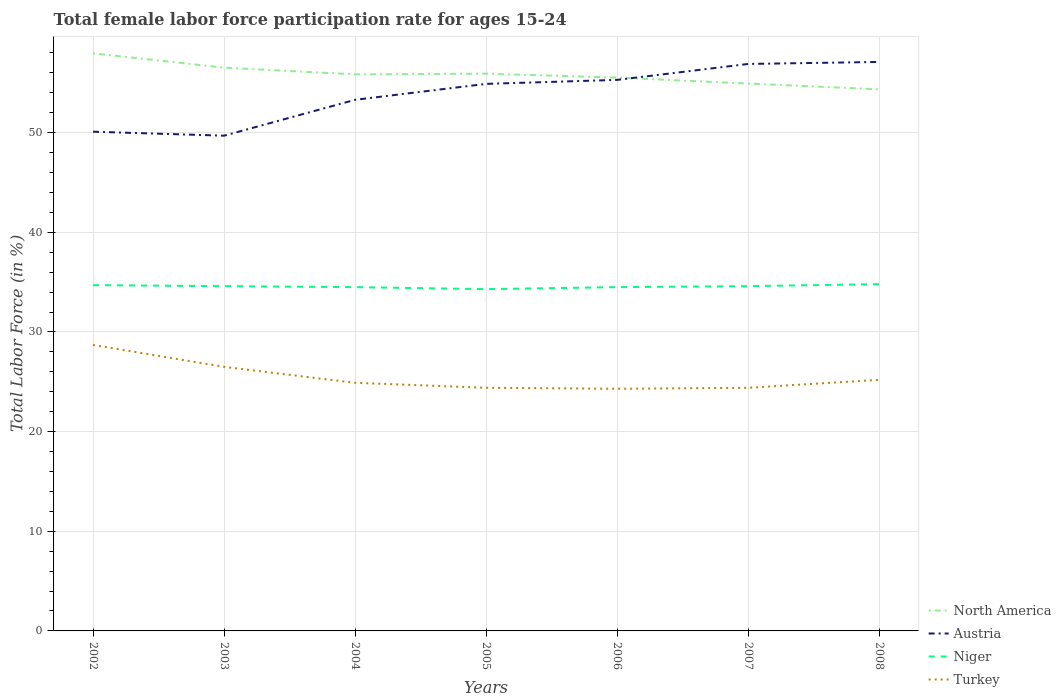Across all years, what is the maximum female labor force participation rate in Austria?
Ensure brevity in your answer.  49.7. In which year was the female labor force participation rate in Niger maximum?
Offer a terse response. 2005. What is the total female labor force participation rate in Austria in the graph?
Offer a terse response. -5.2. What is the difference between the highest and the second highest female labor force participation rate in Turkey?
Provide a succinct answer. 4.4. Is the female labor force participation rate in Niger strictly greater than the female labor force participation rate in Austria over the years?
Your answer should be very brief. Yes. How many lines are there?
Give a very brief answer. 4. Does the graph contain any zero values?
Keep it short and to the point. No. How many legend labels are there?
Provide a succinct answer. 4. How are the legend labels stacked?
Your answer should be compact. Vertical. What is the title of the graph?
Your response must be concise. Total female labor force participation rate for ages 15-24. Does "Benin" appear as one of the legend labels in the graph?
Provide a short and direct response. No. What is the label or title of the X-axis?
Provide a short and direct response. Years. What is the Total Labor Force (in %) in North America in 2002?
Provide a short and direct response. 57.96. What is the Total Labor Force (in %) in Austria in 2002?
Ensure brevity in your answer.  50.1. What is the Total Labor Force (in %) of Niger in 2002?
Keep it short and to the point. 34.7. What is the Total Labor Force (in %) of Turkey in 2002?
Offer a very short reply. 28.7. What is the Total Labor Force (in %) in North America in 2003?
Your response must be concise. 56.53. What is the Total Labor Force (in %) in Austria in 2003?
Your answer should be very brief. 49.7. What is the Total Labor Force (in %) of Niger in 2003?
Offer a very short reply. 34.6. What is the Total Labor Force (in %) in North America in 2004?
Your response must be concise. 55.85. What is the Total Labor Force (in %) in Austria in 2004?
Provide a short and direct response. 53.3. What is the Total Labor Force (in %) in Niger in 2004?
Offer a terse response. 34.5. What is the Total Labor Force (in %) in Turkey in 2004?
Make the answer very short. 24.9. What is the Total Labor Force (in %) of North America in 2005?
Your response must be concise. 55.92. What is the Total Labor Force (in %) in Austria in 2005?
Ensure brevity in your answer.  54.9. What is the Total Labor Force (in %) in Niger in 2005?
Give a very brief answer. 34.3. What is the Total Labor Force (in %) in Turkey in 2005?
Keep it short and to the point. 24.4. What is the Total Labor Force (in %) of North America in 2006?
Ensure brevity in your answer.  55.53. What is the Total Labor Force (in %) in Austria in 2006?
Give a very brief answer. 55.3. What is the Total Labor Force (in %) in Niger in 2006?
Provide a short and direct response. 34.5. What is the Total Labor Force (in %) in Turkey in 2006?
Provide a short and direct response. 24.3. What is the Total Labor Force (in %) of North America in 2007?
Make the answer very short. 54.93. What is the Total Labor Force (in %) of Austria in 2007?
Your response must be concise. 56.9. What is the Total Labor Force (in %) of Niger in 2007?
Your answer should be compact. 34.6. What is the Total Labor Force (in %) in Turkey in 2007?
Offer a terse response. 24.4. What is the Total Labor Force (in %) of North America in 2008?
Your answer should be compact. 54.35. What is the Total Labor Force (in %) in Austria in 2008?
Offer a very short reply. 57.1. What is the Total Labor Force (in %) in Niger in 2008?
Give a very brief answer. 34.8. What is the Total Labor Force (in %) of Turkey in 2008?
Offer a very short reply. 25.2. Across all years, what is the maximum Total Labor Force (in %) of North America?
Give a very brief answer. 57.96. Across all years, what is the maximum Total Labor Force (in %) of Austria?
Keep it short and to the point. 57.1. Across all years, what is the maximum Total Labor Force (in %) of Niger?
Offer a terse response. 34.8. Across all years, what is the maximum Total Labor Force (in %) in Turkey?
Your answer should be very brief. 28.7. Across all years, what is the minimum Total Labor Force (in %) in North America?
Keep it short and to the point. 54.35. Across all years, what is the minimum Total Labor Force (in %) of Austria?
Give a very brief answer. 49.7. Across all years, what is the minimum Total Labor Force (in %) of Niger?
Your answer should be very brief. 34.3. Across all years, what is the minimum Total Labor Force (in %) of Turkey?
Offer a terse response. 24.3. What is the total Total Labor Force (in %) in North America in the graph?
Your answer should be very brief. 391.08. What is the total Total Labor Force (in %) of Austria in the graph?
Give a very brief answer. 377.3. What is the total Total Labor Force (in %) of Niger in the graph?
Your answer should be very brief. 242. What is the total Total Labor Force (in %) of Turkey in the graph?
Your answer should be compact. 178.4. What is the difference between the Total Labor Force (in %) in North America in 2002 and that in 2003?
Give a very brief answer. 1.43. What is the difference between the Total Labor Force (in %) in Niger in 2002 and that in 2003?
Offer a very short reply. 0.1. What is the difference between the Total Labor Force (in %) in Turkey in 2002 and that in 2003?
Your answer should be very brief. 2.2. What is the difference between the Total Labor Force (in %) in North America in 2002 and that in 2004?
Keep it short and to the point. 2.11. What is the difference between the Total Labor Force (in %) of Niger in 2002 and that in 2004?
Your response must be concise. 0.2. What is the difference between the Total Labor Force (in %) of North America in 2002 and that in 2005?
Offer a very short reply. 2.04. What is the difference between the Total Labor Force (in %) in Austria in 2002 and that in 2005?
Your answer should be compact. -4.8. What is the difference between the Total Labor Force (in %) of Turkey in 2002 and that in 2005?
Provide a succinct answer. 4.3. What is the difference between the Total Labor Force (in %) in North America in 2002 and that in 2006?
Your answer should be very brief. 2.43. What is the difference between the Total Labor Force (in %) of North America in 2002 and that in 2007?
Offer a very short reply. 3.03. What is the difference between the Total Labor Force (in %) of Austria in 2002 and that in 2007?
Provide a short and direct response. -6.8. What is the difference between the Total Labor Force (in %) in Turkey in 2002 and that in 2007?
Your response must be concise. 4.3. What is the difference between the Total Labor Force (in %) of North America in 2002 and that in 2008?
Provide a succinct answer. 3.61. What is the difference between the Total Labor Force (in %) in North America in 2003 and that in 2004?
Provide a short and direct response. 0.67. What is the difference between the Total Labor Force (in %) of Niger in 2003 and that in 2004?
Your response must be concise. 0.1. What is the difference between the Total Labor Force (in %) of North America in 2003 and that in 2005?
Give a very brief answer. 0.6. What is the difference between the Total Labor Force (in %) of Austria in 2003 and that in 2005?
Your answer should be compact. -5.2. What is the difference between the Total Labor Force (in %) in Niger in 2003 and that in 2005?
Keep it short and to the point. 0.3. What is the difference between the Total Labor Force (in %) in Turkey in 2003 and that in 2005?
Give a very brief answer. 2.1. What is the difference between the Total Labor Force (in %) of Niger in 2003 and that in 2006?
Offer a terse response. 0.1. What is the difference between the Total Labor Force (in %) in North America in 2003 and that in 2007?
Your answer should be compact. 1.6. What is the difference between the Total Labor Force (in %) of Austria in 2003 and that in 2007?
Keep it short and to the point. -7.2. What is the difference between the Total Labor Force (in %) in Niger in 2003 and that in 2007?
Your response must be concise. 0. What is the difference between the Total Labor Force (in %) in Turkey in 2003 and that in 2007?
Your response must be concise. 2.1. What is the difference between the Total Labor Force (in %) in North America in 2003 and that in 2008?
Offer a terse response. 2.18. What is the difference between the Total Labor Force (in %) in Austria in 2003 and that in 2008?
Your response must be concise. -7.4. What is the difference between the Total Labor Force (in %) of Niger in 2003 and that in 2008?
Provide a short and direct response. -0.2. What is the difference between the Total Labor Force (in %) in North America in 2004 and that in 2005?
Ensure brevity in your answer.  -0.07. What is the difference between the Total Labor Force (in %) of Niger in 2004 and that in 2005?
Your answer should be compact. 0.2. What is the difference between the Total Labor Force (in %) in Turkey in 2004 and that in 2005?
Your response must be concise. 0.5. What is the difference between the Total Labor Force (in %) of North America in 2004 and that in 2006?
Your answer should be very brief. 0.32. What is the difference between the Total Labor Force (in %) in Niger in 2004 and that in 2006?
Give a very brief answer. 0. What is the difference between the Total Labor Force (in %) in Turkey in 2004 and that in 2006?
Your answer should be compact. 0.6. What is the difference between the Total Labor Force (in %) in North America in 2004 and that in 2007?
Offer a very short reply. 0.92. What is the difference between the Total Labor Force (in %) of North America in 2004 and that in 2008?
Provide a short and direct response. 1.51. What is the difference between the Total Labor Force (in %) in Niger in 2004 and that in 2008?
Keep it short and to the point. -0.3. What is the difference between the Total Labor Force (in %) in North America in 2005 and that in 2006?
Make the answer very short. 0.39. What is the difference between the Total Labor Force (in %) of Austria in 2005 and that in 2006?
Give a very brief answer. -0.4. What is the difference between the Total Labor Force (in %) in Niger in 2005 and that in 2006?
Your response must be concise. -0.2. What is the difference between the Total Labor Force (in %) of North America in 2005 and that in 2007?
Provide a succinct answer. 0.99. What is the difference between the Total Labor Force (in %) of Niger in 2005 and that in 2007?
Your answer should be very brief. -0.3. What is the difference between the Total Labor Force (in %) in Turkey in 2005 and that in 2007?
Your answer should be very brief. 0. What is the difference between the Total Labor Force (in %) in North America in 2005 and that in 2008?
Your answer should be compact. 1.57. What is the difference between the Total Labor Force (in %) of Austria in 2005 and that in 2008?
Give a very brief answer. -2.2. What is the difference between the Total Labor Force (in %) of Niger in 2005 and that in 2008?
Provide a succinct answer. -0.5. What is the difference between the Total Labor Force (in %) in Turkey in 2005 and that in 2008?
Your answer should be compact. -0.8. What is the difference between the Total Labor Force (in %) of North America in 2006 and that in 2007?
Your response must be concise. 0.6. What is the difference between the Total Labor Force (in %) of Austria in 2006 and that in 2007?
Offer a very short reply. -1.6. What is the difference between the Total Labor Force (in %) of Niger in 2006 and that in 2007?
Offer a terse response. -0.1. What is the difference between the Total Labor Force (in %) in North America in 2006 and that in 2008?
Your answer should be very brief. 1.18. What is the difference between the Total Labor Force (in %) of Niger in 2006 and that in 2008?
Keep it short and to the point. -0.3. What is the difference between the Total Labor Force (in %) of North America in 2007 and that in 2008?
Provide a succinct answer. 0.58. What is the difference between the Total Labor Force (in %) in Niger in 2007 and that in 2008?
Offer a very short reply. -0.2. What is the difference between the Total Labor Force (in %) of North America in 2002 and the Total Labor Force (in %) of Austria in 2003?
Give a very brief answer. 8.26. What is the difference between the Total Labor Force (in %) of North America in 2002 and the Total Labor Force (in %) of Niger in 2003?
Give a very brief answer. 23.36. What is the difference between the Total Labor Force (in %) in North America in 2002 and the Total Labor Force (in %) in Turkey in 2003?
Give a very brief answer. 31.46. What is the difference between the Total Labor Force (in %) in Austria in 2002 and the Total Labor Force (in %) in Niger in 2003?
Provide a short and direct response. 15.5. What is the difference between the Total Labor Force (in %) in Austria in 2002 and the Total Labor Force (in %) in Turkey in 2003?
Keep it short and to the point. 23.6. What is the difference between the Total Labor Force (in %) in North America in 2002 and the Total Labor Force (in %) in Austria in 2004?
Your answer should be very brief. 4.66. What is the difference between the Total Labor Force (in %) of North America in 2002 and the Total Labor Force (in %) of Niger in 2004?
Offer a terse response. 23.46. What is the difference between the Total Labor Force (in %) of North America in 2002 and the Total Labor Force (in %) of Turkey in 2004?
Provide a succinct answer. 33.06. What is the difference between the Total Labor Force (in %) in Austria in 2002 and the Total Labor Force (in %) in Turkey in 2004?
Offer a very short reply. 25.2. What is the difference between the Total Labor Force (in %) of North America in 2002 and the Total Labor Force (in %) of Austria in 2005?
Offer a very short reply. 3.06. What is the difference between the Total Labor Force (in %) in North America in 2002 and the Total Labor Force (in %) in Niger in 2005?
Offer a very short reply. 23.66. What is the difference between the Total Labor Force (in %) of North America in 2002 and the Total Labor Force (in %) of Turkey in 2005?
Your answer should be very brief. 33.56. What is the difference between the Total Labor Force (in %) of Austria in 2002 and the Total Labor Force (in %) of Niger in 2005?
Provide a short and direct response. 15.8. What is the difference between the Total Labor Force (in %) in Austria in 2002 and the Total Labor Force (in %) in Turkey in 2005?
Your answer should be very brief. 25.7. What is the difference between the Total Labor Force (in %) of North America in 2002 and the Total Labor Force (in %) of Austria in 2006?
Your answer should be compact. 2.66. What is the difference between the Total Labor Force (in %) of North America in 2002 and the Total Labor Force (in %) of Niger in 2006?
Ensure brevity in your answer.  23.46. What is the difference between the Total Labor Force (in %) in North America in 2002 and the Total Labor Force (in %) in Turkey in 2006?
Provide a short and direct response. 33.66. What is the difference between the Total Labor Force (in %) in Austria in 2002 and the Total Labor Force (in %) in Turkey in 2006?
Keep it short and to the point. 25.8. What is the difference between the Total Labor Force (in %) of Niger in 2002 and the Total Labor Force (in %) of Turkey in 2006?
Give a very brief answer. 10.4. What is the difference between the Total Labor Force (in %) of North America in 2002 and the Total Labor Force (in %) of Austria in 2007?
Provide a short and direct response. 1.06. What is the difference between the Total Labor Force (in %) of North America in 2002 and the Total Labor Force (in %) of Niger in 2007?
Give a very brief answer. 23.36. What is the difference between the Total Labor Force (in %) in North America in 2002 and the Total Labor Force (in %) in Turkey in 2007?
Keep it short and to the point. 33.56. What is the difference between the Total Labor Force (in %) of Austria in 2002 and the Total Labor Force (in %) of Turkey in 2007?
Keep it short and to the point. 25.7. What is the difference between the Total Labor Force (in %) of Niger in 2002 and the Total Labor Force (in %) of Turkey in 2007?
Your response must be concise. 10.3. What is the difference between the Total Labor Force (in %) in North America in 2002 and the Total Labor Force (in %) in Austria in 2008?
Offer a very short reply. 0.86. What is the difference between the Total Labor Force (in %) of North America in 2002 and the Total Labor Force (in %) of Niger in 2008?
Your response must be concise. 23.16. What is the difference between the Total Labor Force (in %) in North America in 2002 and the Total Labor Force (in %) in Turkey in 2008?
Offer a terse response. 32.76. What is the difference between the Total Labor Force (in %) of Austria in 2002 and the Total Labor Force (in %) of Niger in 2008?
Give a very brief answer. 15.3. What is the difference between the Total Labor Force (in %) in Austria in 2002 and the Total Labor Force (in %) in Turkey in 2008?
Give a very brief answer. 24.9. What is the difference between the Total Labor Force (in %) in North America in 2003 and the Total Labor Force (in %) in Austria in 2004?
Offer a very short reply. 3.23. What is the difference between the Total Labor Force (in %) in North America in 2003 and the Total Labor Force (in %) in Niger in 2004?
Your answer should be compact. 22.03. What is the difference between the Total Labor Force (in %) in North America in 2003 and the Total Labor Force (in %) in Turkey in 2004?
Keep it short and to the point. 31.63. What is the difference between the Total Labor Force (in %) in Austria in 2003 and the Total Labor Force (in %) in Niger in 2004?
Your answer should be compact. 15.2. What is the difference between the Total Labor Force (in %) of Austria in 2003 and the Total Labor Force (in %) of Turkey in 2004?
Provide a short and direct response. 24.8. What is the difference between the Total Labor Force (in %) in North America in 2003 and the Total Labor Force (in %) in Austria in 2005?
Make the answer very short. 1.63. What is the difference between the Total Labor Force (in %) of North America in 2003 and the Total Labor Force (in %) of Niger in 2005?
Keep it short and to the point. 22.23. What is the difference between the Total Labor Force (in %) in North America in 2003 and the Total Labor Force (in %) in Turkey in 2005?
Ensure brevity in your answer.  32.13. What is the difference between the Total Labor Force (in %) in Austria in 2003 and the Total Labor Force (in %) in Turkey in 2005?
Make the answer very short. 25.3. What is the difference between the Total Labor Force (in %) of Niger in 2003 and the Total Labor Force (in %) of Turkey in 2005?
Your answer should be very brief. 10.2. What is the difference between the Total Labor Force (in %) of North America in 2003 and the Total Labor Force (in %) of Austria in 2006?
Ensure brevity in your answer.  1.23. What is the difference between the Total Labor Force (in %) of North America in 2003 and the Total Labor Force (in %) of Niger in 2006?
Your answer should be compact. 22.03. What is the difference between the Total Labor Force (in %) in North America in 2003 and the Total Labor Force (in %) in Turkey in 2006?
Your answer should be very brief. 32.23. What is the difference between the Total Labor Force (in %) in Austria in 2003 and the Total Labor Force (in %) in Niger in 2006?
Provide a short and direct response. 15.2. What is the difference between the Total Labor Force (in %) of Austria in 2003 and the Total Labor Force (in %) of Turkey in 2006?
Your answer should be very brief. 25.4. What is the difference between the Total Labor Force (in %) of North America in 2003 and the Total Labor Force (in %) of Austria in 2007?
Your answer should be compact. -0.37. What is the difference between the Total Labor Force (in %) in North America in 2003 and the Total Labor Force (in %) in Niger in 2007?
Your answer should be compact. 21.93. What is the difference between the Total Labor Force (in %) in North America in 2003 and the Total Labor Force (in %) in Turkey in 2007?
Your answer should be compact. 32.13. What is the difference between the Total Labor Force (in %) in Austria in 2003 and the Total Labor Force (in %) in Turkey in 2007?
Offer a very short reply. 25.3. What is the difference between the Total Labor Force (in %) of Niger in 2003 and the Total Labor Force (in %) of Turkey in 2007?
Your answer should be compact. 10.2. What is the difference between the Total Labor Force (in %) in North America in 2003 and the Total Labor Force (in %) in Austria in 2008?
Your answer should be very brief. -0.57. What is the difference between the Total Labor Force (in %) in North America in 2003 and the Total Labor Force (in %) in Niger in 2008?
Ensure brevity in your answer.  21.73. What is the difference between the Total Labor Force (in %) of North America in 2003 and the Total Labor Force (in %) of Turkey in 2008?
Offer a terse response. 31.33. What is the difference between the Total Labor Force (in %) in Austria in 2003 and the Total Labor Force (in %) in Niger in 2008?
Your response must be concise. 14.9. What is the difference between the Total Labor Force (in %) of Austria in 2003 and the Total Labor Force (in %) of Turkey in 2008?
Provide a short and direct response. 24.5. What is the difference between the Total Labor Force (in %) of North America in 2004 and the Total Labor Force (in %) of Austria in 2005?
Make the answer very short. 0.95. What is the difference between the Total Labor Force (in %) of North America in 2004 and the Total Labor Force (in %) of Niger in 2005?
Keep it short and to the point. 21.55. What is the difference between the Total Labor Force (in %) in North America in 2004 and the Total Labor Force (in %) in Turkey in 2005?
Offer a terse response. 31.45. What is the difference between the Total Labor Force (in %) of Austria in 2004 and the Total Labor Force (in %) of Niger in 2005?
Make the answer very short. 19. What is the difference between the Total Labor Force (in %) in Austria in 2004 and the Total Labor Force (in %) in Turkey in 2005?
Give a very brief answer. 28.9. What is the difference between the Total Labor Force (in %) of Niger in 2004 and the Total Labor Force (in %) of Turkey in 2005?
Provide a succinct answer. 10.1. What is the difference between the Total Labor Force (in %) of North America in 2004 and the Total Labor Force (in %) of Austria in 2006?
Ensure brevity in your answer.  0.55. What is the difference between the Total Labor Force (in %) in North America in 2004 and the Total Labor Force (in %) in Niger in 2006?
Offer a terse response. 21.35. What is the difference between the Total Labor Force (in %) in North America in 2004 and the Total Labor Force (in %) in Turkey in 2006?
Give a very brief answer. 31.55. What is the difference between the Total Labor Force (in %) of Austria in 2004 and the Total Labor Force (in %) of Turkey in 2006?
Provide a succinct answer. 29. What is the difference between the Total Labor Force (in %) in North America in 2004 and the Total Labor Force (in %) in Austria in 2007?
Make the answer very short. -1.05. What is the difference between the Total Labor Force (in %) in North America in 2004 and the Total Labor Force (in %) in Niger in 2007?
Provide a short and direct response. 21.25. What is the difference between the Total Labor Force (in %) in North America in 2004 and the Total Labor Force (in %) in Turkey in 2007?
Your answer should be compact. 31.45. What is the difference between the Total Labor Force (in %) of Austria in 2004 and the Total Labor Force (in %) of Niger in 2007?
Your answer should be very brief. 18.7. What is the difference between the Total Labor Force (in %) of Austria in 2004 and the Total Labor Force (in %) of Turkey in 2007?
Offer a terse response. 28.9. What is the difference between the Total Labor Force (in %) of Niger in 2004 and the Total Labor Force (in %) of Turkey in 2007?
Keep it short and to the point. 10.1. What is the difference between the Total Labor Force (in %) in North America in 2004 and the Total Labor Force (in %) in Austria in 2008?
Offer a terse response. -1.25. What is the difference between the Total Labor Force (in %) of North America in 2004 and the Total Labor Force (in %) of Niger in 2008?
Provide a succinct answer. 21.05. What is the difference between the Total Labor Force (in %) of North America in 2004 and the Total Labor Force (in %) of Turkey in 2008?
Keep it short and to the point. 30.65. What is the difference between the Total Labor Force (in %) in Austria in 2004 and the Total Labor Force (in %) in Niger in 2008?
Ensure brevity in your answer.  18.5. What is the difference between the Total Labor Force (in %) of Austria in 2004 and the Total Labor Force (in %) of Turkey in 2008?
Your response must be concise. 28.1. What is the difference between the Total Labor Force (in %) of Niger in 2004 and the Total Labor Force (in %) of Turkey in 2008?
Ensure brevity in your answer.  9.3. What is the difference between the Total Labor Force (in %) of North America in 2005 and the Total Labor Force (in %) of Austria in 2006?
Your response must be concise. 0.62. What is the difference between the Total Labor Force (in %) of North America in 2005 and the Total Labor Force (in %) of Niger in 2006?
Offer a terse response. 21.42. What is the difference between the Total Labor Force (in %) in North America in 2005 and the Total Labor Force (in %) in Turkey in 2006?
Your response must be concise. 31.62. What is the difference between the Total Labor Force (in %) in Austria in 2005 and the Total Labor Force (in %) in Niger in 2006?
Your answer should be compact. 20.4. What is the difference between the Total Labor Force (in %) in Austria in 2005 and the Total Labor Force (in %) in Turkey in 2006?
Keep it short and to the point. 30.6. What is the difference between the Total Labor Force (in %) in Niger in 2005 and the Total Labor Force (in %) in Turkey in 2006?
Provide a succinct answer. 10. What is the difference between the Total Labor Force (in %) of North America in 2005 and the Total Labor Force (in %) of Austria in 2007?
Your answer should be very brief. -0.98. What is the difference between the Total Labor Force (in %) in North America in 2005 and the Total Labor Force (in %) in Niger in 2007?
Your answer should be very brief. 21.32. What is the difference between the Total Labor Force (in %) in North America in 2005 and the Total Labor Force (in %) in Turkey in 2007?
Provide a short and direct response. 31.52. What is the difference between the Total Labor Force (in %) in Austria in 2005 and the Total Labor Force (in %) in Niger in 2007?
Your response must be concise. 20.3. What is the difference between the Total Labor Force (in %) of Austria in 2005 and the Total Labor Force (in %) of Turkey in 2007?
Your answer should be compact. 30.5. What is the difference between the Total Labor Force (in %) of Niger in 2005 and the Total Labor Force (in %) of Turkey in 2007?
Offer a terse response. 9.9. What is the difference between the Total Labor Force (in %) of North America in 2005 and the Total Labor Force (in %) of Austria in 2008?
Your answer should be compact. -1.18. What is the difference between the Total Labor Force (in %) of North America in 2005 and the Total Labor Force (in %) of Niger in 2008?
Keep it short and to the point. 21.12. What is the difference between the Total Labor Force (in %) of North America in 2005 and the Total Labor Force (in %) of Turkey in 2008?
Your answer should be very brief. 30.72. What is the difference between the Total Labor Force (in %) in Austria in 2005 and the Total Labor Force (in %) in Niger in 2008?
Offer a very short reply. 20.1. What is the difference between the Total Labor Force (in %) in Austria in 2005 and the Total Labor Force (in %) in Turkey in 2008?
Provide a short and direct response. 29.7. What is the difference between the Total Labor Force (in %) of Niger in 2005 and the Total Labor Force (in %) of Turkey in 2008?
Offer a very short reply. 9.1. What is the difference between the Total Labor Force (in %) in North America in 2006 and the Total Labor Force (in %) in Austria in 2007?
Provide a short and direct response. -1.37. What is the difference between the Total Labor Force (in %) in North America in 2006 and the Total Labor Force (in %) in Niger in 2007?
Ensure brevity in your answer.  20.93. What is the difference between the Total Labor Force (in %) of North America in 2006 and the Total Labor Force (in %) of Turkey in 2007?
Offer a very short reply. 31.13. What is the difference between the Total Labor Force (in %) of Austria in 2006 and the Total Labor Force (in %) of Niger in 2007?
Offer a very short reply. 20.7. What is the difference between the Total Labor Force (in %) of Austria in 2006 and the Total Labor Force (in %) of Turkey in 2007?
Your answer should be compact. 30.9. What is the difference between the Total Labor Force (in %) in Niger in 2006 and the Total Labor Force (in %) in Turkey in 2007?
Keep it short and to the point. 10.1. What is the difference between the Total Labor Force (in %) in North America in 2006 and the Total Labor Force (in %) in Austria in 2008?
Provide a short and direct response. -1.57. What is the difference between the Total Labor Force (in %) in North America in 2006 and the Total Labor Force (in %) in Niger in 2008?
Keep it short and to the point. 20.73. What is the difference between the Total Labor Force (in %) in North America in 2006 and the Total Labor Force (in %) in Turkey in 2008?
Ensure brevity in your answer.  30.33. What is the difference between the Total Labor Force (in %) in Austria in 2006 and the Total Labor Force (in %) in Turkey in 2008?
Keep it short and to the point. 30.1. What is the difference between the Total Labor Force (in %) of Niger in 2006 and the Total Labor Force (in %) of Turkey in 2008?
Your answer should be compact. 9.3. What is the difference between the Total Labor Force (in %) of North America in 2007 and the Total Labor Force (in %) of Austria in 2008?
Offer a very short reply. -2.17. What is the difference between the Total Labor Force (in %) in North America in 2007 and the Total Labor Force (in %) in Niger in 2008?
Provide a succinct answer. 20.13. What is the difference between the Total Labor Force (in %) of North America in 2007 and the Total Labor Force (in %) of Turkey in 2008?
Your answer should be compact. 29.73. What is the difference between the Total Labor Force (in %) in Austria in 2007 and the Total Labor Force (in %) in Niger in 2008?
Ensure brevity in your answer.  22.1. What is the difference between the Total Labor Force (in %) of Austria in 2007 and the Total Labor Force (in %) of Turkey in 2008?
Your answer should be very brief. 31.7. What is the average Total Labor Force (in %) of North America per year?
Offer a very short reply. 55.87. What is the average Total Labor Force (in %) in Austria per year?
Your response must be concise. 53.9. What is the average Total Labor Force (in %) in Niger per year?
Offer a very short reply. 34.57. What is the average Total Labor Force (in %) of Turkey per year?
Offer a terse response. 25.49. In the year 2002, what is the difference between the Total Labor Force (in %) in North America and Total Labor Force (in %) in Austria?
Provide a succinct answer. 7.86. In the year 2002, what is the difference between the Total Labor Force (in %) of North America and Total Labor Force (in %) of Niger?
Your answer should be very brief. 23.26. In the year 2002, what is the difference between the Total Labor Force (in %) in North America and Total Labor Force (in %) in Turkey?
Make the answer very short. 29.26. In the year 2002, what is the difference between the Total Labor Force (in %) of Austria and Total Labor Force (in %) of Niger?
Provide a short and direct response. 15.4. In the year 2002, what is the difference between the Total Labor Force (in %) in Austria and Total Labor Force (in %) in Turkey?
Offer a terse response. 21.4. In the year 2002, what is the difference between the Total Labor Force (in %) of Niger and Total Labor Force (in %) of Turkey?
Make the answer very short. 6. In the year 2003, what is the difference between the Total Labor Force (in %) of North America and Total Labor Force (in %) of Austria?
Your answer should be very brief. 6.83. In the year 2003, what is the difference between the Total Labor Force (in %) of North America and Total Labor Force (in %) of Niger?
Offer a very short reply. 21.93. In the year 2003, what is the difference between the Total Labor Force (in %) of North America and Total Labor Force (in %) of Turkey?
Offer a terse response. 30.03. In the year 2003, what is the difference between the Total Labor Force (in %) in Austria and Total Labor Force (in %) in Niger?
Give a very brief answer. 15.1. In the year 2003, what is the difference between the Total Labor Force (in %) of Austria and Total Labor Force (in %) of Turkey?
Your answer should be very brief. 23.2. In the year 2004, what is the difference between the Total Labor Force (in %) of North America and Total Labor Force (in %) of Austria?
Offer a very short reply. 2.55. In the year 2004, what is the difference between the Total Labor Force (in %) of North America and Total Labor Force (in %) of Niger?
Make the answer very short. 21.35. In the year 2004, what is the difference between the Total Labor Force (in %) of North America and Total Labor Force (in %) of Turkey?
Give a very brief answer. 30.95. In the year 2004, what is the difference between the Total Labor Force (in %) of Austria and Total Labor Force (in %) of Niger?
Your answer should be very brief. 18.8. In the year 2004, what is the difference between the Total Labor Force (in %) of Austria and Total Labor Force (in %) of Turkey?
Give a very brief answer. 28.4. In the year 2005, what is the difference between the Total Labor Force (in %) of North America and Total Labor Force (in %) of Austria?
Offer a very short reply. 1.02. In the year 2005, what is the difference between the Total Labor Force (in %) of North America and Total Labor Force (in %) of Niger?
Give a very brief answer. 21.62. In the year 2005, what is the difference between the Total Labor Force (in %) in North America and Total Labor Force (in %) in Turkey?
Provide a succinct answer. 31.52. In the year 2005, what is the difference between the Total Labor Force (in %) of Austria and Total Labor Force (in %) of Niger?
Ensure brevity in your answer.  20.6. In the year 2005, what is the difference between the Total Labor Force (in %) of Austria and Total Labor Force (in %) of Turkey?
Ensure brevity in your answer.  30.5. In the year 2005, what is the difference between the Total Labor Force (in %) in Niger and Total Labor Force (in %) in Turkey?
Offer a very short reply. 9.9. In the year 2006, what is the difference between the Total Labor Force (in %) of North America and Total Labor Force (in %) of Austria?
Your answer should be very brief. 0.23. In the year 2006, what is the difference between the Total Labor Force (in %) in North America and Total Labor Force (in %) in Niger?
Make the answer very short. 21.03. In the year 2006, what is the difference between the Total Labor Force (in %) of North America and Total Labor Force (in %) of Turkey?
Offer a terse response. 31.23. In the year 2006, what is the difference between the Total Labor Force (in %) of Austria and Total Labor Force (in %) of Niger?
Your answer should be very brief. 20.8. In the year 2006, what is the difference between the Total Labor Force (in %) of Austria and Total Labor Force (in %) of Turkey?
Ensure brevity in your answer.  31. In the year 2007, what is the difference between the Total Labor Force (in %) of North America and Total Labor Force (in %) of Austria?
Provide a short and direct response. -1.97. In the year 2007, what is the difference between the Total Labor Force (in %) in North America and Total Labor Force (in %) in Niger?
Keep it short and to the point. 20.33. In the year 2007, what is the difference between the Total Labor Force (in %) of North America and Total Labor Force (in %) of Turkey?
Keep it short and to the point. 30.53. In the year 2007, what is the difference between the Total Labor Force (in %) in Austria and Total Labor Force (in %) in Niger?
Make the answer very short. 22.3. In the year 2007, what is the difference between the Total Labor Force (in %) of Austria and Total Labor Force (in %) of Turkey?
Keep it short and to the point. 32.5. In the year 2007, what is the difference between the Total Labor Force (in %) in Niger and Total Labor Force (in %) in Turkey?
Your answer should be compact. 10.2. In the year 2008, what is the difference between the Total Labor Force (in %) in North America and Total Labor Force (in %) in Austria?
Provide a succinct answer. -2.75. In the year 2008, what is the difference between the Total Labor Force (in %) in North America and Total Labor Force (in %) in Niger?
Offer a terse response. 19.55. In the year 2008, what is the difference between the Total Labor Force (in %) of North America and Total Labor Force (in %) of Turkey?
Give a very brief answer. 29.15. In the year 2008, what is the difference between the Total Labor Force (in %) of Austria and Total Labor Force (in %) of Niger?
Your response must be concise. 22.3. In the year 2008, what is the difference between the Total Labor Force (in %) in Austria and Total Labor Force (in %) in Turkey?
Ensure brevity in your answer.  31.9. In the year 2008, what is the difference between the Total Labor Force (in %) in Niger and Total Labor Force (in %) in Turkey?
Make the answer very short. 9.6. What is the ratio of the Total Labor Force (in %) of North America in 2002 to that in 2003?
Ensure brevity in your answer.  1.03. What is the ratio of the Total Labor Force (in %) in Turkey in 2002 to that in 2003?
Offer a terse response. 1.08. What is the ratio of the Total Labor Force (in %) of North America in 2002 to that in 2004?
Ensure brevity in your answer.  1.04. What is the ratio of the Total Labor Force (in %) in Austria in 2002 to that in 2004?
Offer a very short reply. 0.94. What is the ratio of the Total Labor Force (in %) of Turkey in 2002 to that in 2004?
Make the answer very short. 1.15. What is the ratio of the Total Labor Force (in %) in North America in 2002 to that in 2005?
Ensure brevity in your answer.  1.04. What is the ratio of the Total Labor Force (in %) of Austria in 2002 to that in 2005?
Your response must be concise. 0.91. What is the ratio of the Total Labor Force (in %) in Niger in 2002 to that in 2005?
Your answer should be compact. 1.01. What is the ratio of the Total Labor Force (in %) of Turkey in 2002 to that in 2005?
Your answer should be compact. 1.18. What is the ratio of the Total Labor Force (in %) of North America in 2002 to that in 2006?
Provide a short and direct response. 1.04. What is the ratio of the Total Labor Force (in %) of Austria in 2002 to that in 2006?
Your response must be concise. 0.91. What is the ratio of the Total Labor Force (in %) in Niger in 2002 to that in 2006?
Ensure brevity in your answer.  1.01. What is the ratio of the Total Labor Force (in %) in Turkey in 2002 to that in 2006?
Provide a succinct answer. 1.18. What is the ratio of the Total Labor Force (in %) of North America in 2002 to that in 2007?
Offer a terse response. 1.06. What is the ratio of the Total Labor Force (in %) of Austria in 2002 to that in 2007?
Offer a very short reply. 0.88. What is the ratio of the Total Labor Force (in %) in Turkey in 2002 to that in 2007?
Your answer should be very brief. 1.18. What is the ratio of the Total Labor Force (in %) of North America in 2002 to that in 2008?
Ensure brevity in your answer.  1.07. What is the ratio of the Total Labor Force (in %) of Austria in 2002 to that in 2008?
Provide a short and direct response. 0.88. What is the ratio of the Total Labor Force (in %) of Niger in 2002 to that in 2008?
Make the answer very short. 1. What is the ratio of the Total Labor Force (in %) in Turkey in 2002 to that in 2008?
Ensure brevity in your answer.  1.14. What is the ratio of the Total Labor Force (in %) of North America in 2003 to that in 2004?
Give a very brief answer. 1.01. What is the ratio of the Total Labor Force (in %) of Austria in 2003 to that in 2004?
Your response must be concise. 0.93. What is the ratio of the Total Labor Force (in %) of Niger in 2003 to that in 2004?
Your answer should be compact. 1. What is the ratio of the Total Labor Force (in %) in Turkey in 2003 to that in 2004?
Your answer should be compact. 1.06. What is the ratio of the Total Labor Force (in %) of North America in 2003 to that in 2005?
Ensure brevity in your answer.  1.01. What is the ratio of the Total Labor Force (in %) in Austria in 2003 to that in 2005?
Provide a succinct answer. 0.91. What is the ratio of the Total Labor Force (in %) of Niger in 2003 to that in 2005?
Provide a succinct answer. 1.01. What is the ratio of the Total Labor Force (in %) of Turkey in 2003 to that in 2005?
Ensure brevity in your answer.  1.09. What is the ratio of the Total Labor Force (in %) in North America in 2003 to that in 2006?
Give a very brief answer. 1.02. What is the ratio of the Total Labor Force (in %) of Austria in 2003 to that in 2006?
Your answer should be very brief. 0.9. What is the ratio of the Total Labor Force (in %) in Niger in 2003 to that in 2006?
Give a very brief answer. 1. What is the ratio of the Total Labor Force (in %) of Turkey in 2003 to that in 2006?
Provide a succinct answer. 1.09. What is the ratio of the Total Labor Force (in %) in North America in 2003 to that in 2007?
Offer a very short reply. 1.03. What is the ratio of the Total Labor Force (in %) in Austria in 2003 to that in 2007?
Make the answer very short. 0.87. What is the ratio of the Total Labor Force (in %) in Turkey in 2003 to that in 2007?
Offer a very short reply. 1.09. What is the ratio of the Total Labor Force (in %) of North America in 2003 to that in 2008?
Ensure brevity in your answer.  1.04. What is the ratio of the Total Labor Force (in %) in Austria in 2003 to that in 2008?
Provide a short and direct response. 0.87. What is the ratio of the Total Labor Force (in %) in Turkey in 2003 to that in 2008?
Your answer should be compact. 1.05. What is the ratio of the Total Labor Force (in %) of North America in 2004 to that in 2005?
Your response must be concise. 1. What is the ratio of the Total Labor Force (in %) of Austria in 2004 to that in 2005?
Your response must be concise. 0.97. What is the ratio of the Total Labor Force (in %) in Turkey in 2004 to that in 2005?
Provide a short and direct response. 1.02. What is the ratio of the Total Labor Force (in %) of North America in 2004 to that in 2006?
Make the answer very short. 1.01. What is the ratio of the Total Labor Force (in %) in Austria in 2004 to that in 2006?
Give a very brief answer. 0.96. What is the ratio of the Total Labor Force (in %) of Niger in 2004 to that in 2006?
Your answer should be very brief. 1. What is the ratio of the Total Labor Force (in %) in Turkey in 2004 to that in 2006?
Offer a terse response. 1.02. What is the ratio of the Total Labor Force (in %) of North America in 2004 to that in 2007?
Offer a very short reply. 1.02. What is the ratio of the Total Labor Force (in %) in Austria in 2004 to that in 2007?
Make the answer very short. 0.94. What is the ratio of the Total Labor Force (in %) of Niger in 2004 to that in 2007?
Make the answer very short. 1. What is the ratio of the Total Labor Force (in %) of Turkey in 2004 to that in 2007?
Your answer should be very brief. 1.02. What is the ratio of the Total Labor Force (in %) of North America in 2004 to that in 2008?
Keep it short and to the point. 1.03. What is the ratio of the Total Labor Force (in %) of Austria in 2004 to that in 2008?
Provide a succinct answer. 0.93. What is the ratio of the Total Labor Force (in %) of North America in 2005 to that in 2006?
Offer a very short reply. 1.01. What is the ratio of the Total Labor Force (in %) of Austria in 2005 to that in 2006?
Your response must be concise. 0.99. What is the ratio of the Total Labor Force (in %) in Niger in 2005 to that in 2006?
Ensure brevity in your answer.  0.99. What is the ratio of the Total Labor Force (in %) in Turkey in 2005 to that in 2006?
Keep it short and to the point. 1. What is the ratio of the Total Labor Force (in %) of North America in 2005 to that in 2007?
Your answer should be very brief. 1.02. What is the ratio of the Total Labor Force (in %) of Austria in 2005 to that in 2007?
Your answer should be compact. 0.96. What is the ratio of the Total Labor Force (in %) in Turkey in 2005 to that in 2007?
Make the answer very short. 1. What is the ratio of the Total Labor Force (in %) of North America in 2005 to that in 2008?
Offer a very short reply. 1.03. What is the ratio of the Total Labor Force (in %) in Austria in 2005 to that in 2008?
Ensure brevity in your answer.  0.96. What is the ratio of the Total Labor Force (in %) in Niger in 2005 to that in 2008?
Give a very brief answer. 0.99. What is the ratio of the Total Labor Force (in %) in Turkey in 2005 to that in 2008?
Provide a succinct answer. 0.97. What is the ratio of the Total Labor Force (in %) of North America in 2006 to that in 2007?
Give a very brief answer. 1.01. What is the ratio of the Total Labor Force (in %) in Austria in 2006 to that in 2007?
Ensure brevity in your answer.  0.97. What is the ratio of the Total Labor Force (in %) of North America in 2006 to that in 2008?
Make the answer very short. 1.02. What is the ratio of the Total Labor Force (in %) in Austria in 2006 to that in 2008?
Offer a terse response. 0.97. What is the ratio of the Total Labor Force (in %) in Niger in 2006 to that in 2008?
Provide a succinct answer. 0.99. What is the ratio of the Total Labor Force (in %) of Turkey in 2006 to that in 2008?
Ensure brevity in your answer.  0.96. What is the ratio of the Total Labor Force (in %) of North America in 2007 to that in 2008?
Offer a very short reply. 1.01. What is the ratio of the Total Labor Force (in %) in Austria in 2007 to that in 2008?
Ensure brevity in your answer.  1. What is the ratio of the Total Labor Force (in %) of Turkey in 2007 to that in 2008?
Give a very brief answer. 0.97. What is the difference between the highest and the second highest Total Labor Force (in %) of North America?
Your answer should be very brief. 1.43. What is the difference between the highest and the second highest Total Labor Force (in %) of Niger?
Keep it short and to the point. 0.1. What is the difference between the highest and the lowest Total Labor Force (in %) in North America?
Your answer should be compact. 3.61. What is the difference between the highest and the lowest Total Labor Force (in %) of Niger?
Keep it short and to the point. 0.5. 